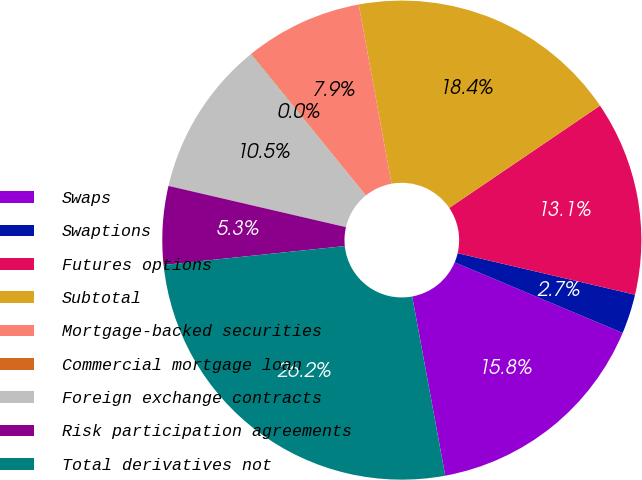<chart> <loc_0><loc_0><loc_500><loc_500><pie_chart><fcel>Swaps<fcel>Swaptions<fcel>Futures options<fcel>Subtotal<fcel>Mortgage-backed securities<fcel>Commercial mortgage loan<fcel>Foreign exchange contracts<fcel>Risk participation agreements<fcel>Total derivatives not<nl><fcel>15.77%<fcel>2.67%<fcel>13.15%<fcel>18.39%<fcel>7.91%<fcel>0.05%<fcel>10.53%<fcel>5.29%<fcel>26.25%<nl></chart> 